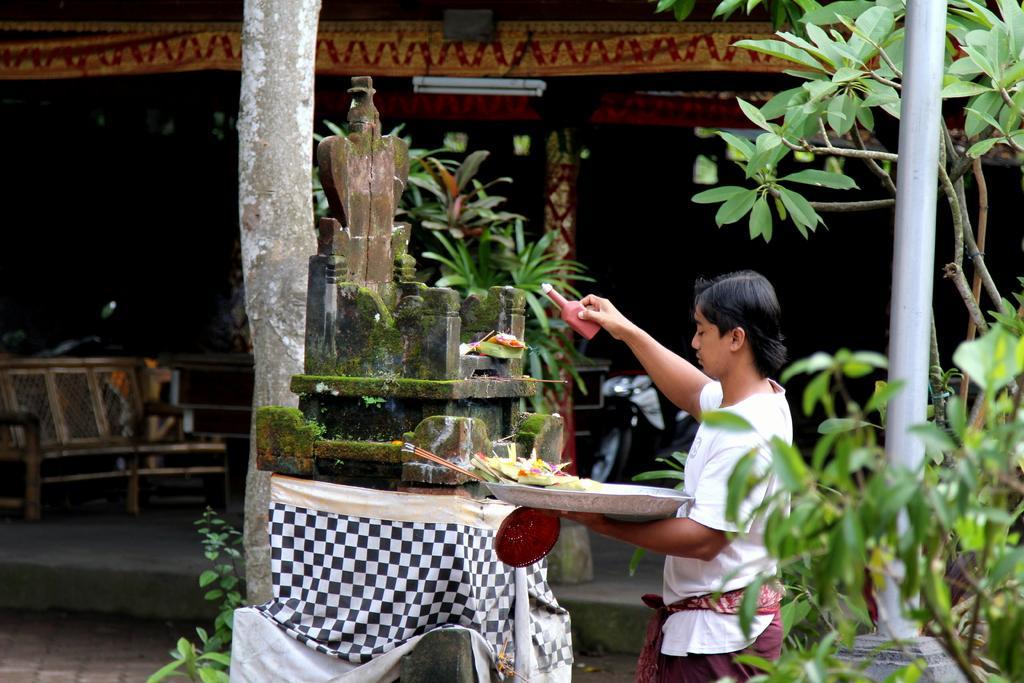How would you summarize this image in a sentence or two? In this image we can see a person holding a bottle and some other items. In front of him there is a stone idol. On the right side there is a pole and there are plants. On the left side there is a bench. In the back there is a shed with tube light. 